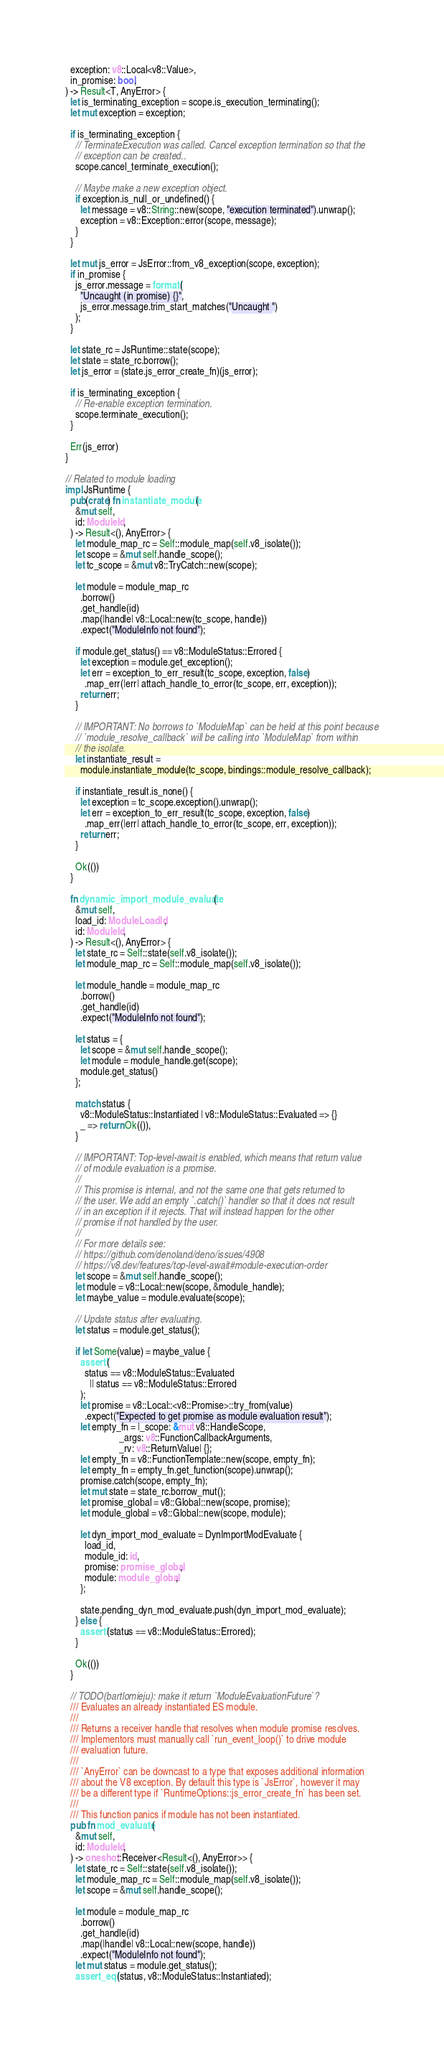Convert code to text. <code><loc_0><loc_0><loc_500><loc_500><_Rust_>  exception: v8::Local<v8::Value>,
  in_promise: bool,
) -> Result<T, AnyError> {
  let is_terminating_exception = scope.is_execution_terminating();
  let mut exception = exception;

  if is_terminating_exception {
    // TerminateExecution was called. Cancel exception termination so that the
    // exception can be created..
    scope.cancel_terminate_execution();

    // Maybe make a new exception object.
    if exception.is_null_or_undefined() {
      let message = v8::String::new(scope, "execution terminated").unwrap();
      exception = v8::Exception::error(scope, message);
    }
  }

  let mut js_error = JsError::from_v8_exception(scope, exception);
  if in_promise {
    js_error.message = format!(
      "Uncaught (in promise) {}",
      js_error.message.trim_start_matches("Uncaught ")
    );
  }

  let state_rc = JsRuntime::state(scope);
  let state = state_rc.borrow();
  let js_error = (state.js_error_create_fn)(js_error);

  if is_terminating_exception {
    // Re-enable exception termination.
    scope.terminate_execution();
  }

  Err(js_error)
}

// Related to module loading
impl JsRuntime {
  pub(crate) fn instantiate_module(
    &mut self,
    id: ModuleId,
  ) -> Result<(), AnyError> {
    let module_map_rc = Self::module_map(self.v8_isolate());
    let scope = &mut self.handle_scope();
    let tc_scope = &mut v8::TryCatch::new(scope);

    let module = module_map_rc
      .borrow()
      .get_handle(id)
      .map(|handle| v8::Local::new(tc_scope, handle))
      .expect("ModuleInfo not found");

    if module.get_status() == v8::ModuleStatus::Errored {
      let exception = module.get_exception();
      let err = exception_to_err_result(tc_scope, exception, false)
        .map_err(|err| attach_handle_to_error(tc_scope, err, exception));
      return err;
    }

    // IMPORTANT: No borrows to `ModuleMap` can be held at this point because
    // `module_resolve_callback` will be calling into `ModuleMap` from within
    // the isolate.
    let instantiate_result =
      module.instantiate_module(tc_scope, bindings::module_resolve_callback);

    if instantiate_result.is_none() {
      let exception = tc_scope.exception().unwrap();
      let err = exception_to_err_result(tc_scope, exception, false)
        .map_err(|err| attach_handle_to_error(tc_scope, err, exception));
      return err;
    }

    Ok(())
  }

  fn dynamic_import_module_evaluate(
    &mut self,
    load_id: ModuleLoadId,
    id: ModuleId,
  ) -> Result<(), AnyError> {
    let state_rc = Self::state(self.v8_isolate());
    let module_map_rc = Self::module_map(self.v8_isolate());

    let module_handle = module_map_rc
      .borrow()
      .get_handle(id)
      .expect("ModuleInfo not found");

    let status = {
      let scope = &mut self.handle_scope();
      let module = module_handle.get(scope);
      module.get_status()
    };

    match status {
      v8::ModuleStatus::Instantiated | v8::ModuleStatus::Evaluated => {}
      _ => return Ok(()),
    }

    // IMPORTANT: Top-level-await is enabled, which means that return value
    // of module evaluation is a promise.
    //
    // This promise is internal, and not the same one that gets returned to
    // the user. We add an empty `.catch()` handler so that it does not result
    // in an exception if it rejects. That will instead happen for the other
    // promise if not handled by the user.
    //
    // For more details see:
    // https://github.com/denoland/deno/issues/4908
    // https://v8.dev/features/top-level-await#module-execution-order
    let scope = &mut self.handle_scope();
    let module = v8::Local::new(scope, &module_handle);
    let maybe_value = module.evaluate(scope);

    // Update status after evaluating.
    let status = module.get_status();

    if let Some(value) = maybe_value {
      assert!(
        status == v8::ModuleStatus::Evaluated
          || status == v8::ModuleStatus::Errored
      );
      let promise = v8::Local::<v8::Promise>::try_from(value)
        .expect("Expected to get promise as module evaluation result");
      let empty_fn = |_scope: &mut v8::HandleScope,
                      _args: v8::FunctionCallbackArguments,
                      _rv: v8::ReturnValue| {};
      let empty_fn = v8::FunctionTemplate::new(scope, empty_fn);
      let empty_fn = empty_fn.get_function(scope).unwrap();
      promise.catch(scope, empty_fn);
      let mut state = state_rc.borrow_mut();
      let promise_global = v8::Global::new(scope, promise);
      let module_global = v8::Global::new(scope, module);

      let dyn_import_mod_evaluate = DynImportModEvaluate {
        load_id,
        module_id: id,
        promise: promise_global,
        module: module_global,
      };

      state.pending_dyn_mod_evaluate.push(dyn_import_mod_evaluate);
    } else {
      assert!(status == v8::ModuleStatus::Errored);
    }

    Ok(())
  }

  // TODO(bartlomieju): make it return `ModuleEvaluationFuture`?
  /// Evaluates an already instantiated ES module.
  ///
  /// Returns a receiver handle that resolves when module promise resolves.
  /// Implementors must manually call `run_event_loop()` to drive module
  /// evaluation future.
  ///
  /// `AnyError` can be downcast to a type that exposes additional information
  /// about the V8 exception. By default this type is `JsError`, however it may
  /// be a different type if `RuntimeOptions::js_error_create_fn` has been set.
  ///
  /// This function panics if module has not been instantiated.
  pub fn mod_evaluate(
    &mut self,
    id: ModuleId,
  ) -> oneshot::Receiver<Result<(), AnyError>> {
    let state_rc = Self::state(self.v8_isolate());
    let module_map_rc = Self::module_map(self.v8_isolate());
    let scope = &mut self.handle_scope();

    let module = module_map_rc
      .borrow()
      .get_handle(id)
      .map(|handle| v8::Local::new(scope, handle))
      .expect("ModuleInfo not found");
    let mut status = module.get_status();
    assert_eq!(status, v8::ModuleStatus::Instantiated);
</code> 